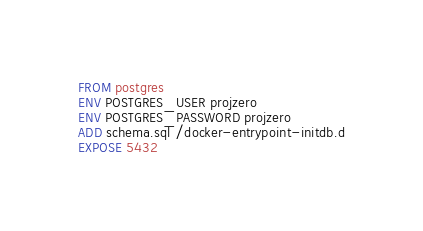Convert code to text. <code><loc_0><loc_0><loc_500><loc_500><_Dockerfile_>
FROM postgres
ENV POSTGRES_USER projzero
ENV POSTGRES_PASSWORD projzero
ADD schema.sql /docker-entrypoint-initdb.d
EXPOSE 5432
</code> 